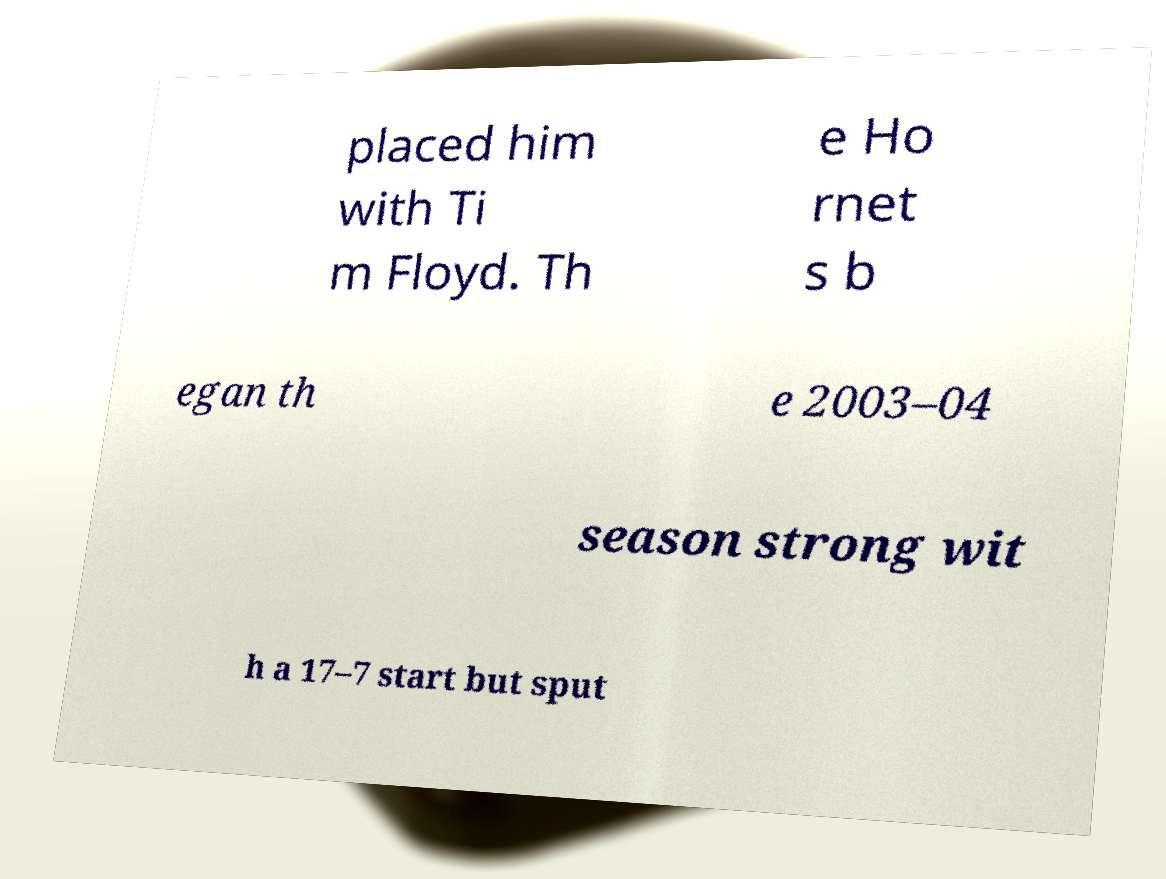I need the written content from this picture converted into text. Can you do that? placed him with Ti m Floyd. Th e Ho rnet s b egan th e 2003–04 season strong wit h a 17–7 start but sput 